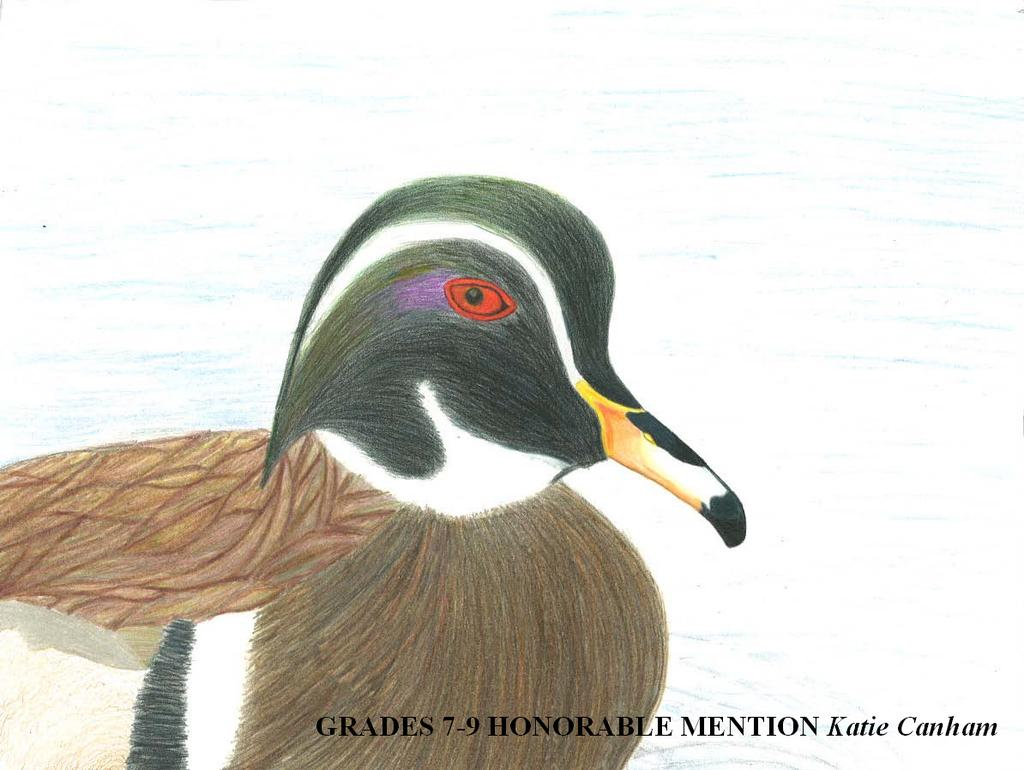What type of artwork is shown in the image? The image is a painting. What subject is depicted in the painting? The painting depicts a duck. What colors are used to paint the duck? The duck is in black and other colors. Where can the title of the painting be found? The name of the painting is at the bottom in black color. What type of notebook is the duck using in the image? There is no notebook present in the image; it is a painting of a duck. Can you tell me the name of the duck's brother in the image? There is no mention of a brother or any other ducks in the image; it only depicts a single duck. 